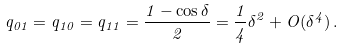<formula> <loc_0><loc_0><loc_500><loc_500>q _ { 0 1 } = q _ { 1 0 } = q _ { 1 1 } = \frac { 1 - \cos \delta } { 2 } = \frac { 1 } { 4 } \delta ^ { 2 } + O ( \delta ^ { 4 } ) \, .</formula> 